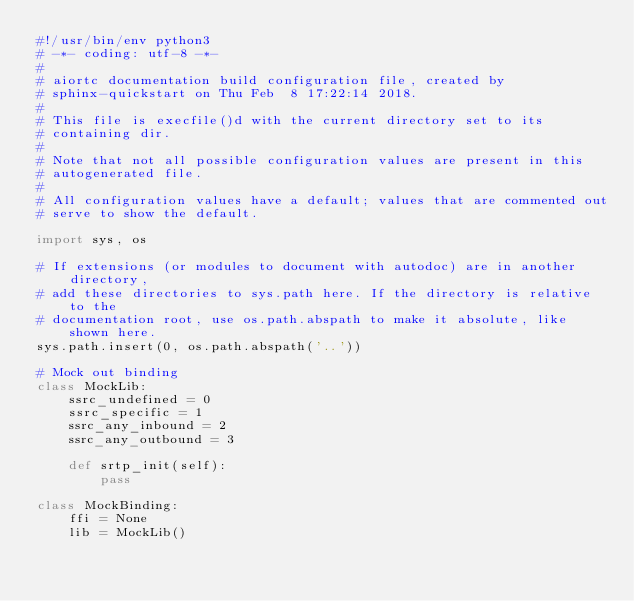Convert code to text. <code><loc_0><loc_0><loc_500><loc_500><_Python_>#!/usr/bin/env python3
# -*- coding: utf-8 -*-
#
# aiortc documentation build configuration file, created by
# sphinx-quickstart on Thu Feb  8 17:22:14 2018.
#
# This file is execfile()d with the current directory set to its
# containing dir.
#
# Note that not all possible configuration values are present in this
# autogenerated file.
#
# All configuration values have a default; values that are commented out
# serve to show the default.

import sys, os

# If extensions (or modules to document with autodoc) are in another directory,
# add these directories to sys.path here. If the directory is relative to the
# documentation root, use os.path.abspath to make it absolute, like shown here.
sys.path.insert(0, os.path.abspath('..'))

# Mock out binding
class MockLib:
    ssrc_undefined = 0
    ssrc_specific = 1
    ssrc_any_inbound = 2
    ssrc_any_outbound = 3

    def srtp_init(self):
        pass

class MockBinding:
    ffi = None
    lib = MockLib()

</code> 